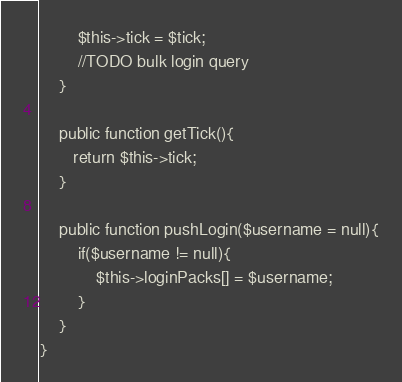Convert code to text. <code><loc_0><loc_0><loc_500><loc_500><_PHP_>        $this->tick = $tick;
        //TODO bulk login query
    }
    
    public function getTick(){
       return $this->tick;
    }
    
    public function pushLogin($username = null){
        if($username != null){
            $this->loginPacks[] = $username;
        }
    }
}</code> 